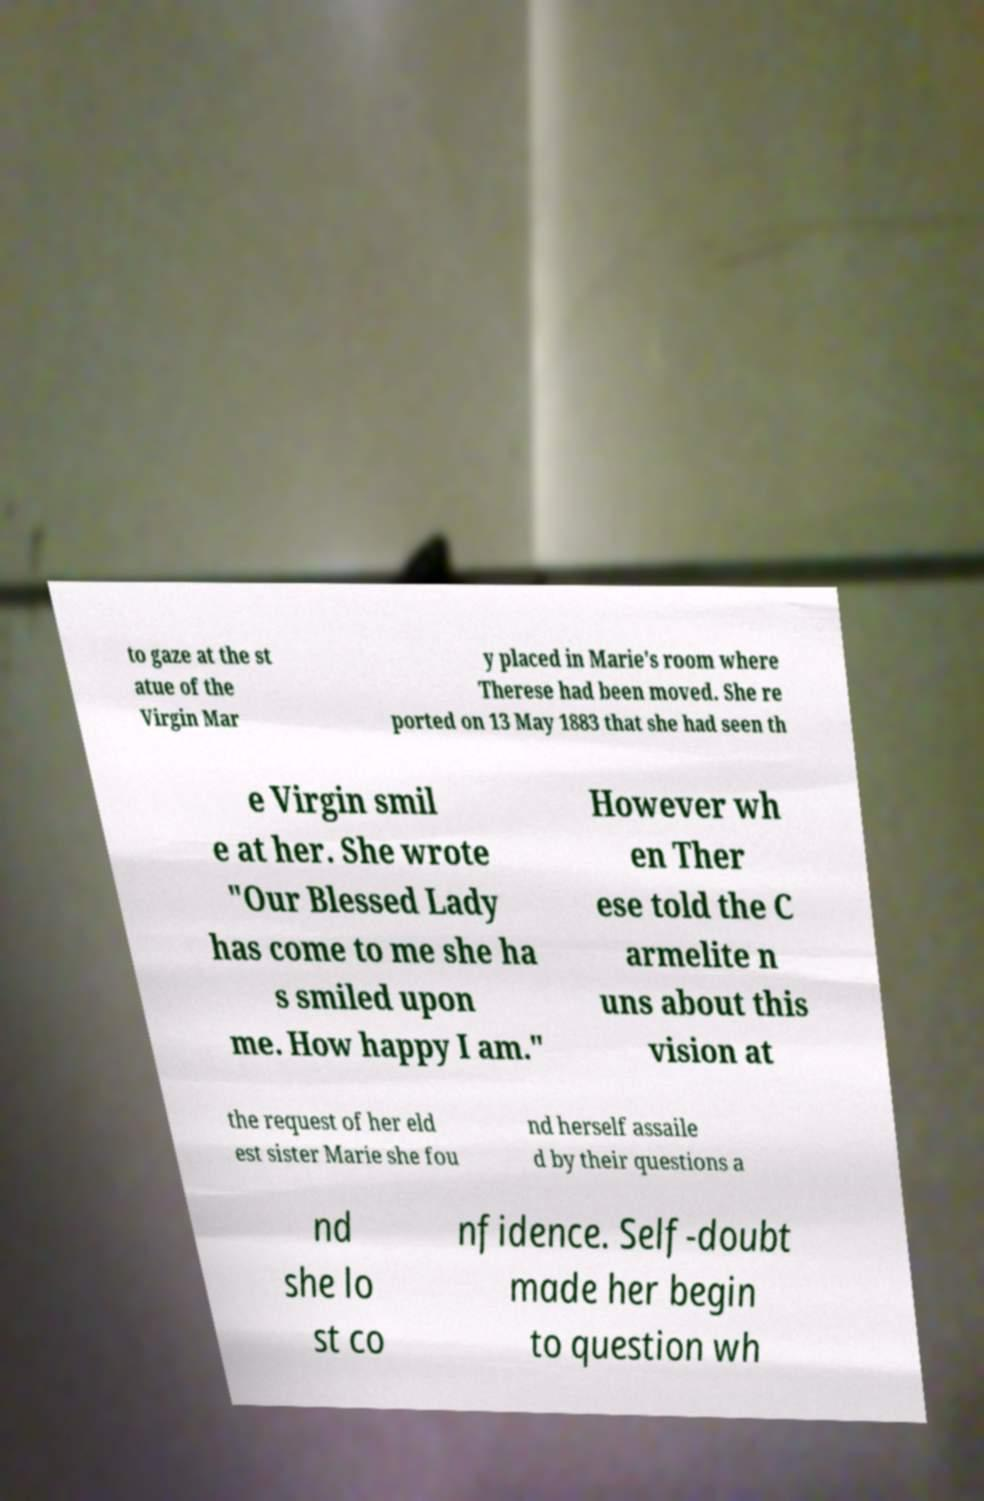Can you accurately transcribe the text from the provided image for me? to gaze at the st atue of the Virgin Mar y placed in Marie's room where Therese had been moved. She re ported on 13 May 1883 that she had seen th e Virgin smil e at her. She wrote "Our Blessed Lady has come to me she ha s smiled upon me. How happy I am." However wh en Ther ese told the C armelite n uns about this vision at the request of her eld est sister Marie she fou nd herself assaile d by their questions a nd she lo st co nfidence. Self-doubt made her begin to question wh 